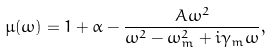Convert formula to latex. <formula><loc_0><loc_0><loc_500><loc_500>\mu ( \omega ) = 1 + \alpha - \frac { A \omega ^ { 2 } } { \omega ^ { 2 } - \omega _ { m } ^ { 2 } + i \gamma _ { m } \omega } ,</formula> 